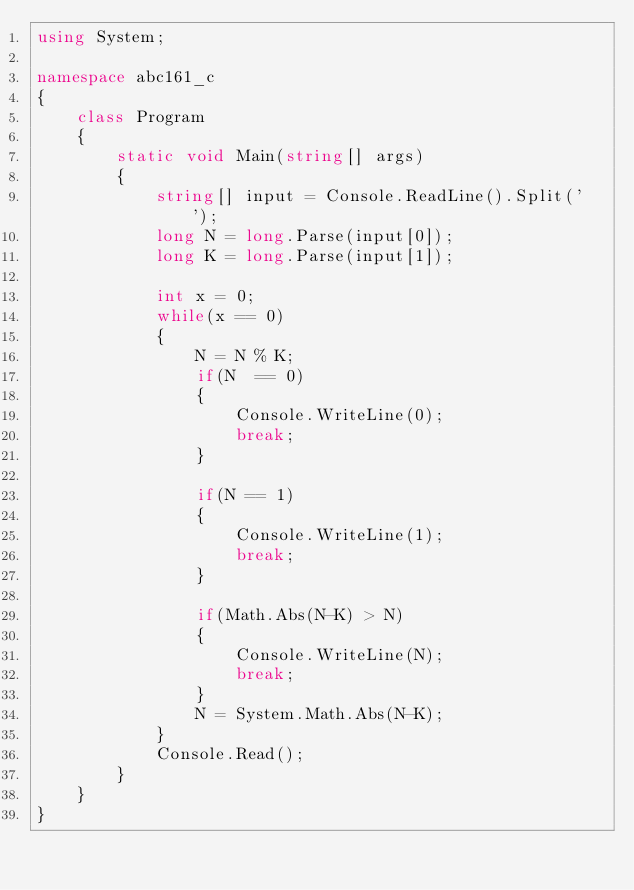<code> <loc_0><loc_0><loc_500><loc_500><_C#_>using System;

namespace abc161_c
{
    class Program
    {
        static void Main(string[] args)
        {
            string[] input = Console.ReadLine().Split(' ');
            long N = long.Parse(input[0]);
            long K = long.Parse(input[1]);

            int x = 0;
            while(x == 0)
            {
                N = N % K;
                if(N  == 0)
                {
                    Console.WriteLine(0);
                    break;
                }

                if(N == 1)
                {
                    Console.WriteLine(1);
                    break;
                }

                if(Math.Abs(N-K) > N)
                {
                    Console.WriteLine(N);
                    break;
                }
                N = System.Math.Abs(N-K);
            }
            Console.Read();
        }
    }
}
</code> 